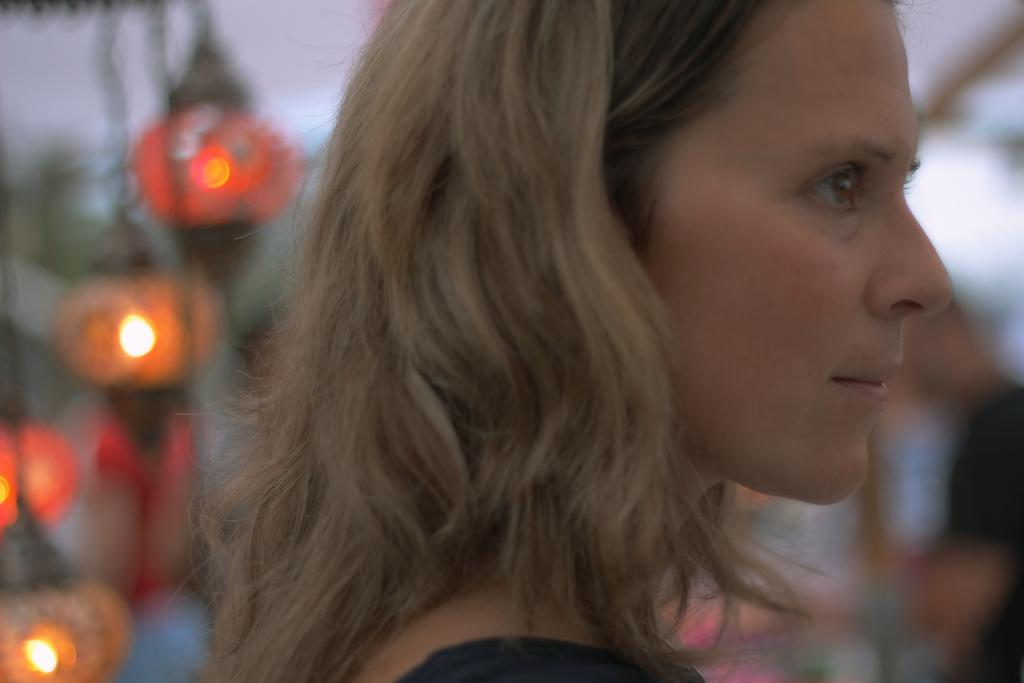What is the main subject of the image? There is a person in the image. How is the background of the image depicted? The background of the image is blurred. Can you describe the objects in the background of the image? Unfortunately, the provided facts do not give any information about the objects in the background. What type of question is being asked by the person in the image? There is no information about the person asking a question in the image. 